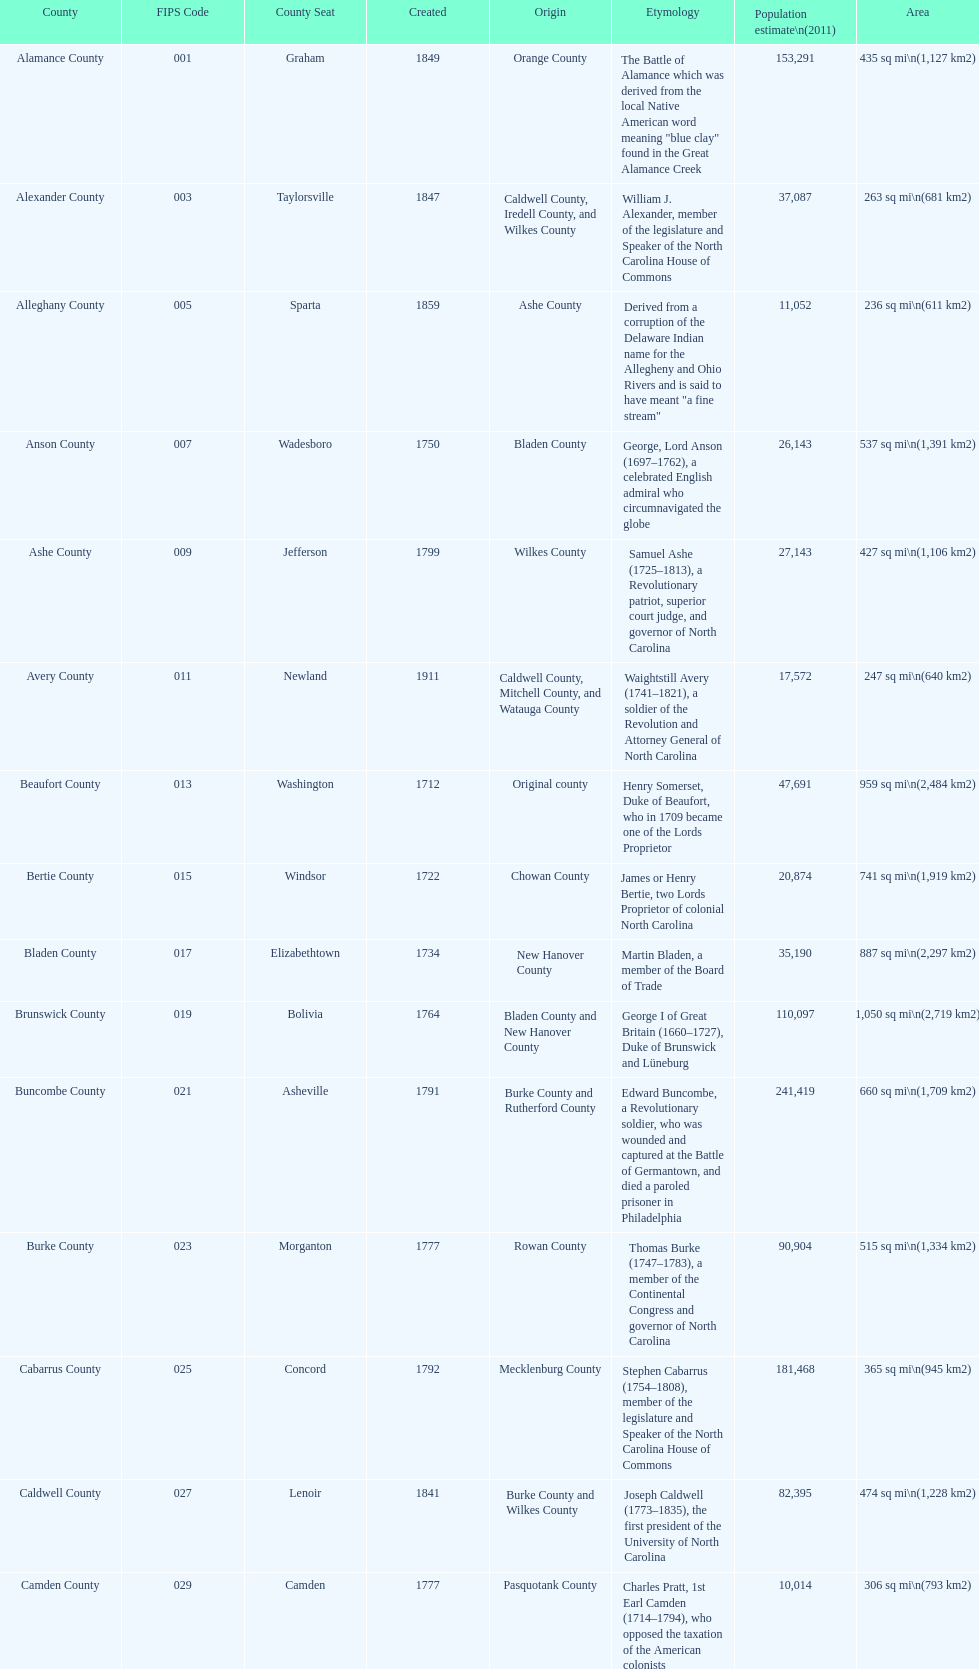Which county has a higher population, alamance or alexander? Alamance County. 